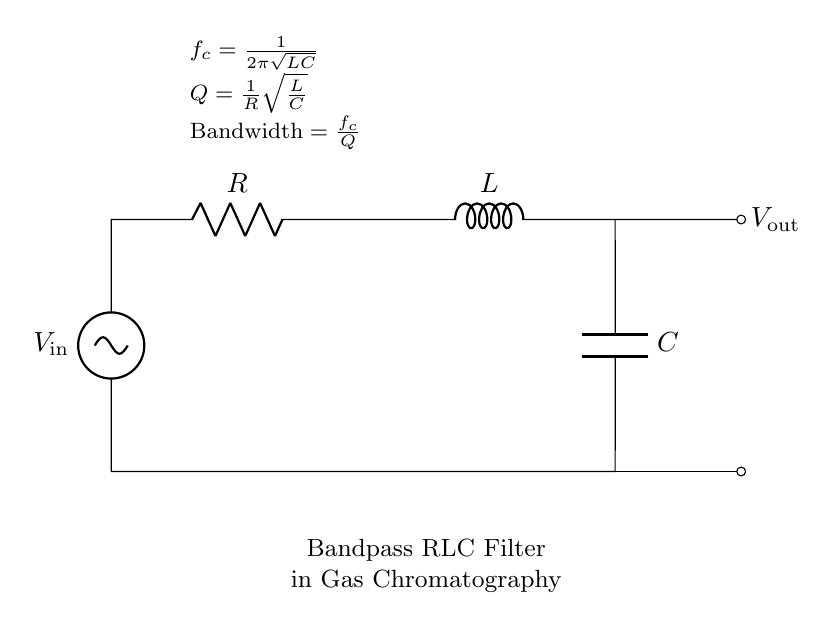What type of filter is represented by this circuit? The circuit is a bandpass RLC filter, which is evident from its configuration of a resistor, inductor, and capacitor arranged to allow specific frequency ranges to pass while attenuating others.
Answer: Bandpass RLC filter What does the variable "Q" represent in this circuit? The variable "Q" represents the quality factor, which is defined in the diagram and indicates the sharpness of the resonance peak in the filter's frequency response.
Answer: Quality factor What is the formula for the cutoff frequency "f_c" in this circuit? The formula for cutoff frequency "f_c" is given in the diagram as 1 divided by the product of 2π and the square root of the product of L and C, showing how it depends on these reactive components.
Answer: 1 over 2π√(LC) How does increasing the resistance "R" affect the bandwidth of the filter? Increasing the resistance "R" decreases the quality factor "Q," which in turn results in a wider bandwidth as the filter allows a broader range of frequencies to pass through.
Answer: Wider bandwidth What happens to the output voltage when the input frequency matches the cutoff frequency? At the cutoff frequency, the output voltage reaches a peak value due to the resonance effect, as the circuit is designed to amplify signals at this specific frequency more than those at others.
Answer: Peak output voltage What is the relationship between "L," "C," and "f_c"? The relationship indicates that the cutoff frequency "f_c" is inversely proportional to the square root of the product of inductance "L" and capacitance "C," meaning changes in either component will affect the frequency at which the circuit resonates.
Answer: Inverse proportionality 